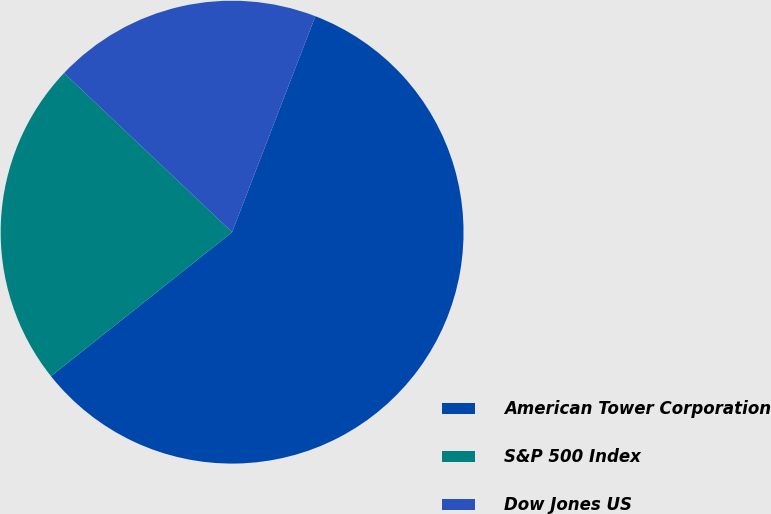Convert chart to OTSL. <chart><loc_0><loc_0><loc_500><loc_500><pie_chart><fcel>American Tower Corporation<fcel>S&P 500 Index<fcel>Dow Jones US<nl><fcel>58.45%<fcel>22.76%<fcel>18.79%<nl></chart> 